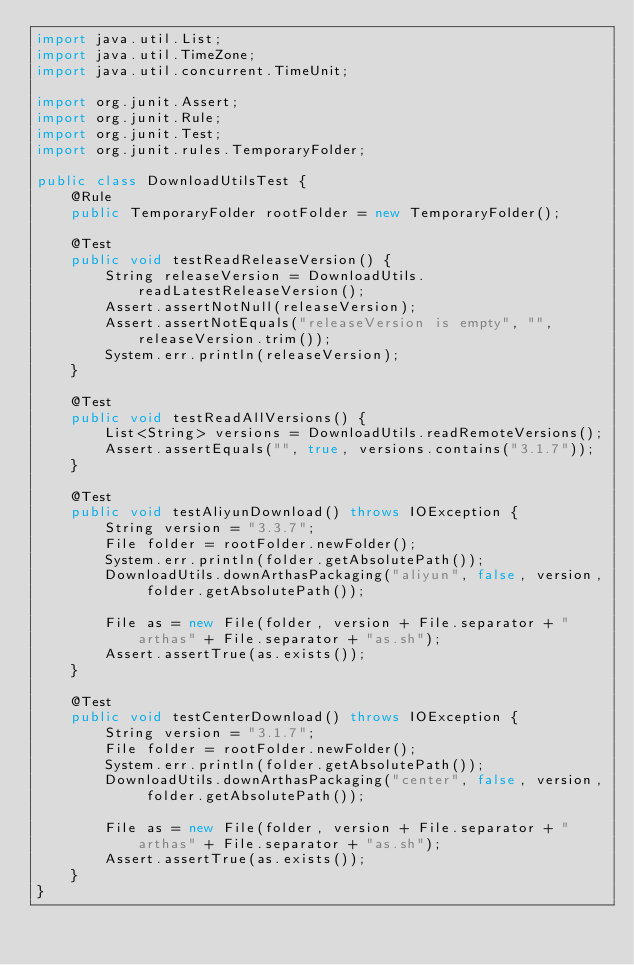<code> <loc_0><loc_0><loc_500><loc_500><_Java_>import java.util.List;
import java.util.TimeZone;
import java.util.concurrent.TimeUnit;

import org.junit.Assert;
import org.junit.Rule;
import org.junit.Test;
import org.junit.rules.TemporaryFolder;

public class DownloadUtilsTest {
    @Rule
    public TemporaryFolder rootFolder = new TemporaryFolder();

    @Test
    public void testReadReleaseVersion() {
        String releaseVersion = DownloadUtils.readLatestReleaseVersion();
        Assert.assertNotNull(releaseVersion);
        Assert.assertNotEquals("releaseVersion is empty", "", releaseVersion.trim());
        System.err.println(releaseVersion);
    }

    @Test
    public void testReadAllVersions() {
        List<String> versions = DownloadUtils.readRemoteVersions();
        Assert.assertEquals("", true, versions.contains("3.1.7"));
    }

    @Test
    public void testAliyunDownload() throws IOException {
        String version = "3.3.7";
        File folder = rootFolder.newFolder();
        System.err.println(folder.getAbsolutePath());
        DownloadUtils.downArthasPackaging("aliyun", false, version, folder.getAbsolutePath());

        File as = new File(folder, version + File.separator + "arthas" + File.separator + "as.sh");
        Assert.assertTrue(as.exists());
    }

    @Test
    public void testCenterDownload() throws IOException {
        String version = "3.1.7";
        File folder = rootFolder.newFolder();
        System.err.println(folder.getAbsolutePath());
        DownloadUtils.downArthasPackaging("center", false, version, folder.getAbsolutePath());

        File as = new File(folder, version + File.separator + "arthas" + File.separator + "as.sh");
        Assert.assertTrue(as.exists());
    }
}
</code> 